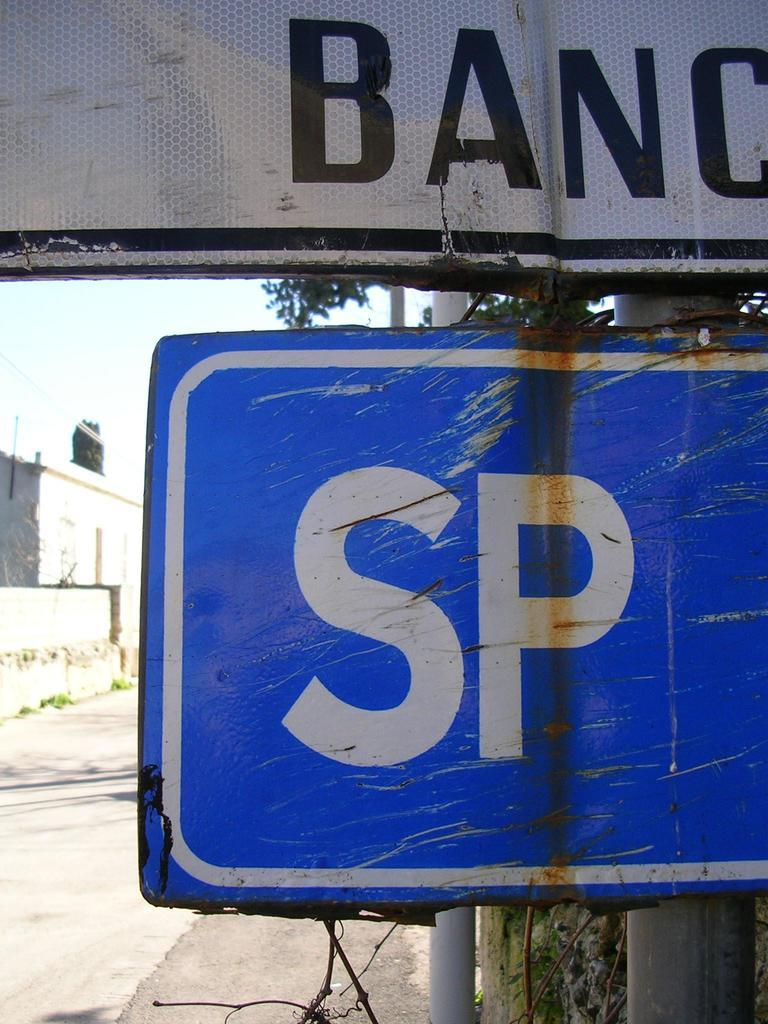<image>
Relay a brief, clear account of the picture shown. a close up of a sign with SP on it under a BanC sign 